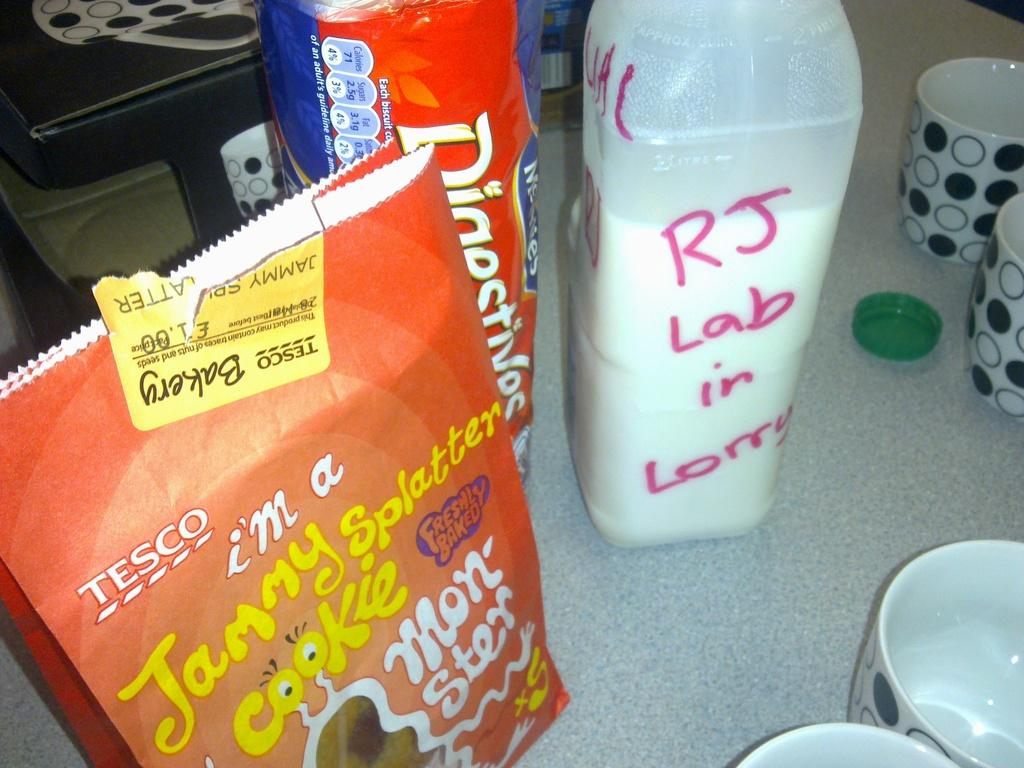What type of containers are visible in the image? There are cups and a milk bottle in the image. What other item can be seen in the image? There is a cap in the image. What might be used to hold or package items in the image? There are packs in the image. Where is the sofa located in the image? There is no sofa present in the image. What shape is the school in the image? There is no school present in the image. 